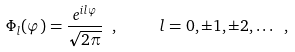Convert formula to latex. <formula><loc_0><loc_0><loc_500><loc_500>\Phi _ { l } ( \varphi ) = \frac { e ^ { i l \varphi } } { \sqrt { 2 \pi } } \ , \quad \ l = 0 , \pm 1 , \pm 2 , \dots \ ,</formula> 